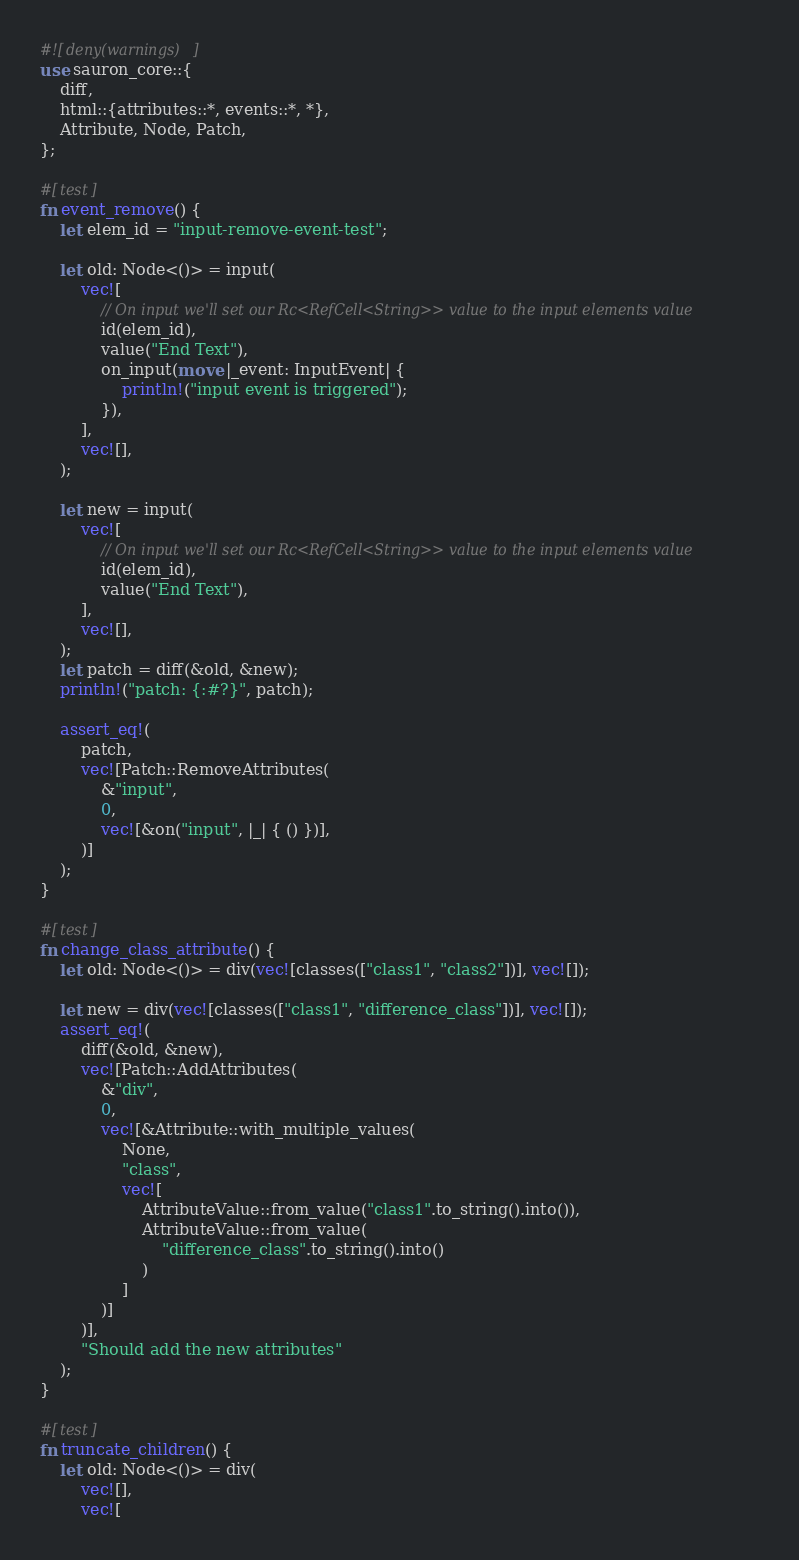Convert code to text. <code><loc_0><loc_0><loc_500><loc_500><_Rust_>#![deny(warnings)]
use sauron_core::{
    diff,
    html::{attributes::*, events::*, *},
    Attribute, Node, Patch,
};

#[test]
fn event_remove() {
    let elem_id = "input-remove-event-test";

    let old: Node<()> = input(
        vec![
            // On input we'll set our Rc<RefCell<String>> value to the input elements value
            id(elem_id),
            value("End Text"),
            on_input(move |_event: InputEvent| {
                println!("input event is triggered");
            }),
        ],
        vec![],
    );

    let new = input(
        vec![
            // On input we'll set our Rc<RefCell<String>> value to the input elements value
            id(elem_id),
            value("End Text"),
        ],
        vec![],
    );
    let patch = diff(&old, &new);
    println!("patch: {:#?}", patch);

    assert_eq!(
        patch,
        vec![Patch::RemoveAttributes(
            &"input",
            0,
            vec![&on("input", |_| { () })],
        )]
    );
}

#[test]
fn change_class_attribute() {
    let old: Node<()> = div(vec![classes(["class1", "class2"])], vec![]);

    let new = div(vec![classes(["class1", "difference_class"])], vec![]);
    assert_eq!(
        diff(&old, &new),
        vec![Patch::AddAttributes(
            &"div",
            0,
            vec![&Attribute::with_multiple_values(
                None,
                "class",
                vec![
                    AttributeValue::from_value("class1".to_string().into()),
                    AttributeValue::from_value(
                        "difference_class".to_string().into()
                    )
                ]
            )]
        )],
        "Should add the new attributes"
    );
}

#[test]
fn truncate_children() {
    let old: Node<()> = div(
        vec![],
        vec![</code> 